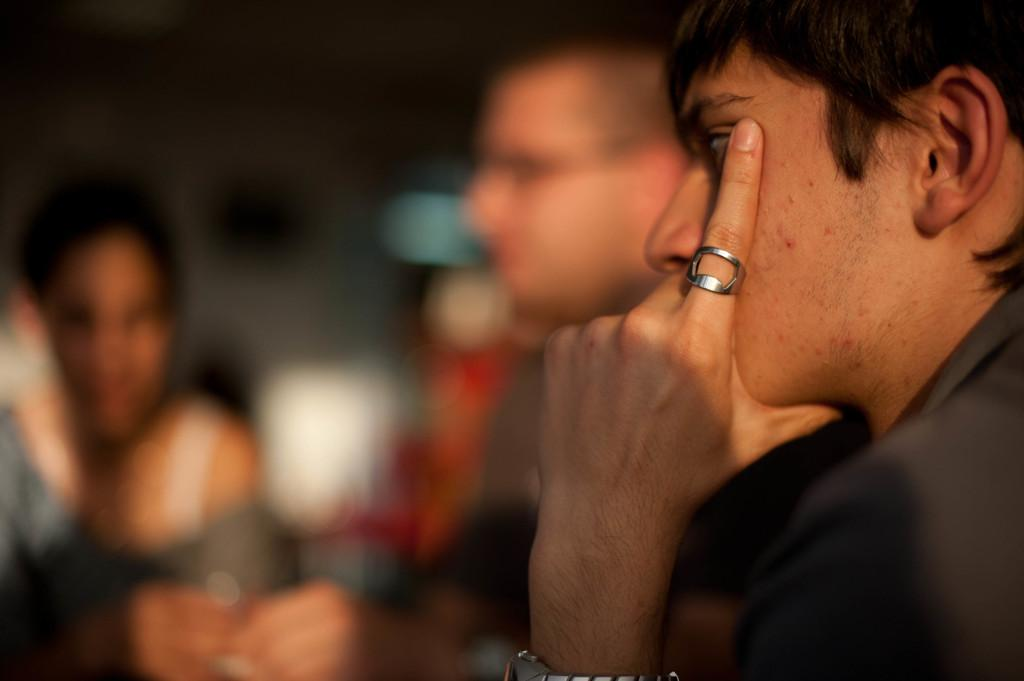What is located on the right side of the image? There is a person on the right side of the image. Can you describe the people in the background of the image? There are a few people in the background of the image. How would you describe the background of the image? The background of the image is blurry. What type of plants can be seen growing on the person's spoon in the image? There is no spoon or plants present in the image. 